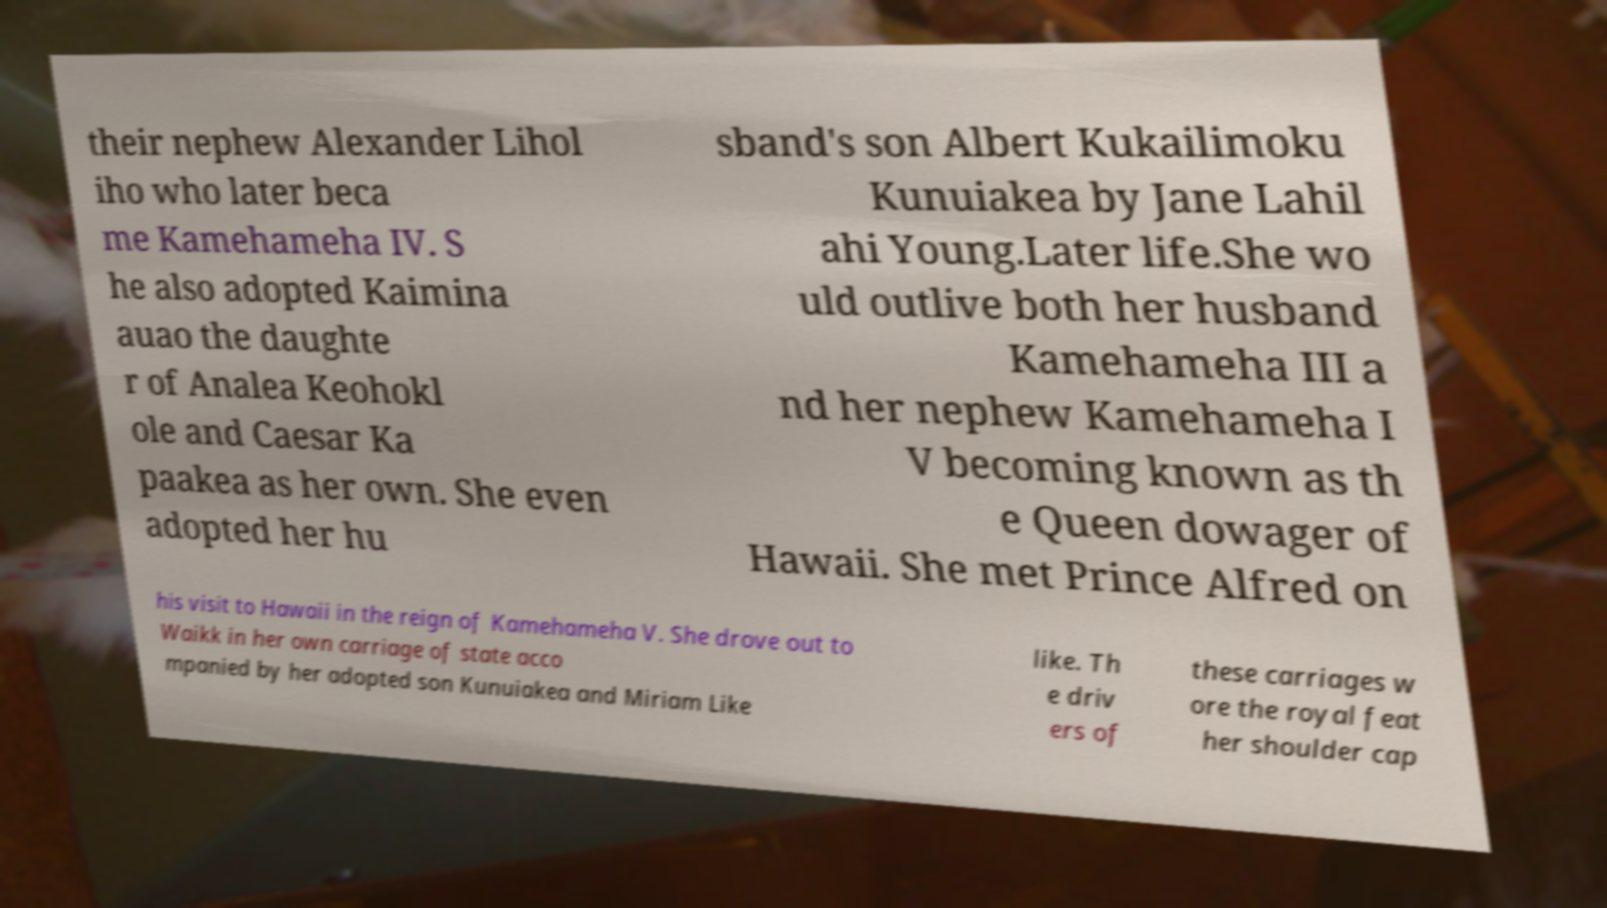Can you read and provide the text displayed in the image?This photo seems to have some interesting text. Can you extract and type it out for me? their nephew Alexander Lihol iho who later beca me Kamehameha IV. S he also adopted Kaimina auao the daughte r of Analea Keohokl ole and Caesar Ka paakea as her own. She even adopted her hu sband's son Albert Kukailimoku Kunuiakea by Jane Lahil ahi Young.Later life.She wo uld outlive both her husband Kamehameha III a nd her nephew Kamehameha I V becoming known as th e Queen dowager of Hawaii. She met Prince Alfred on his visit to Hawaii in the reign of Kamehameha V. She drove out to Waikk in her own carriage of state acco mpanied by her adopted son Kunuiakea and Miriam Like like. Th e driv ers of these carriages w ore the royal feat her shoulder cap 